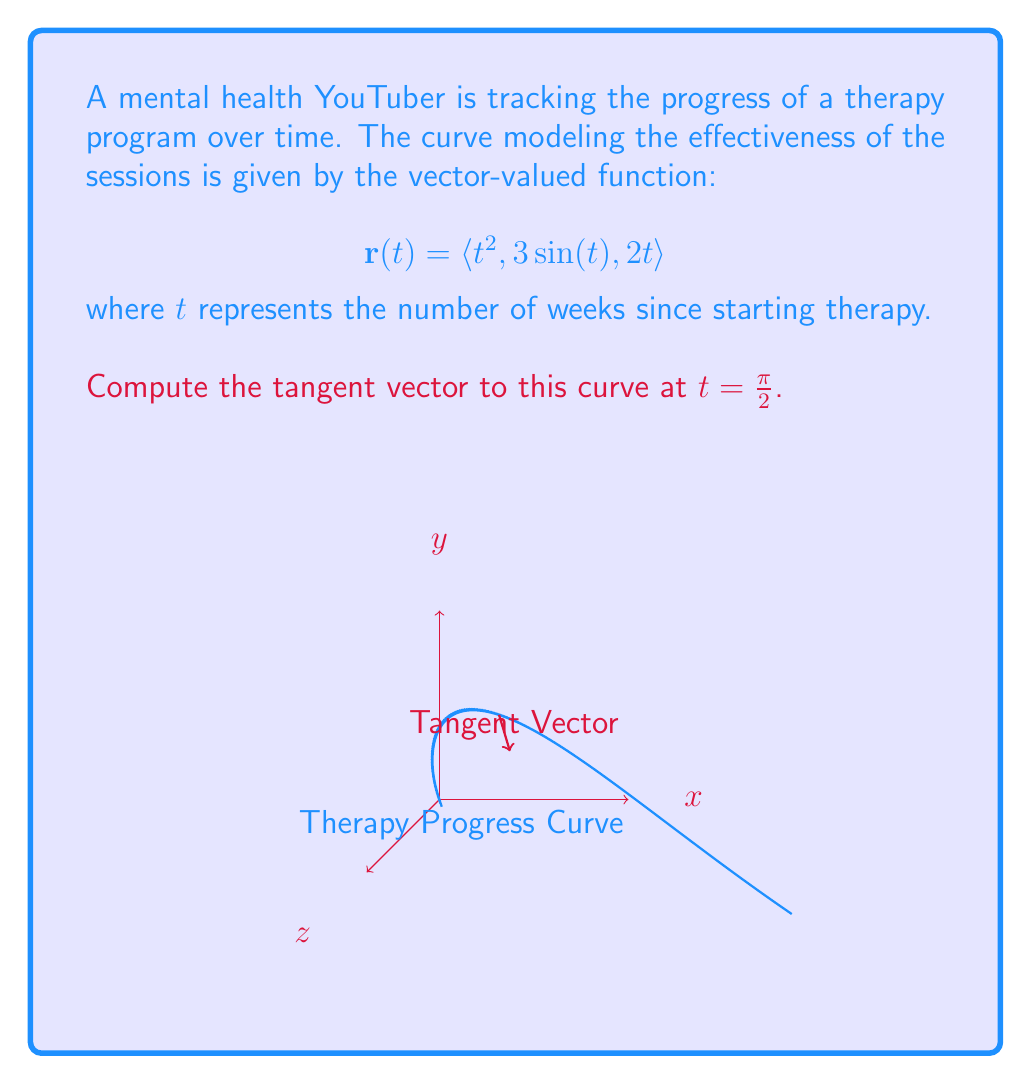Can you solve this math problem? To find the tangent vector to the curve at $t = \frac{\pi}{2}$, we need to calculate $\mathbf{r}'(\frac{\pi}{2})$. Let's approach this step-by-step:

1) First, we need to find $\mathbf{r}'(t)$. This is done by differentiating each component of $\mathbf{r}(t)$ with respect to $t$:

   $$\mathbf{r}'(t) = \langle \frac{d}{dt}(t^2), \frac{d}{dt}(3\sin(t)), \frac{d}{dt}(2t) \rangle$$

2) Applying the differentiation rules:

   $$\mathbf{r}'(t) = \langle 2t, 3\cos(t), 2 \rangle$$

3) Now, we need to evaluate this at $t = \frac{\pi}{2}$:

   $$\mathbf{r}'(\frac{\pi}{2}) = \langle 2(\frac{\pi}{2}), 3\cos(\frac{\pi}{2}), 2 \rangle$$

4) Simplify:
   - $2(\frac{\pi}{2}) = \pi$
   - $\cos(\frac{\pi}{2}) = 0$

5) Therefore, the tangent vector at $t = \frac{\pi}{2}$ is:

   $$\mathbf{r}'(\frac{\pi}{2}) = \langle \pi, 0, 2 \rangle$$

This vector represents the instantaneous rate of change in the therapy progress at 
$\frac{\pi}{2}$ weeks into the program, with components corresponding to different aspects of progress.
Answer: $\langle \pi, 0, 2 \rangle$ 